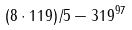Convert formula to latex. <formula><loc_0><loc_0><loc_500><loc_500>( 8 \cdot 1 1 9 ) / 5 - 3 1 9 ^ { 9 7 }</formula> 